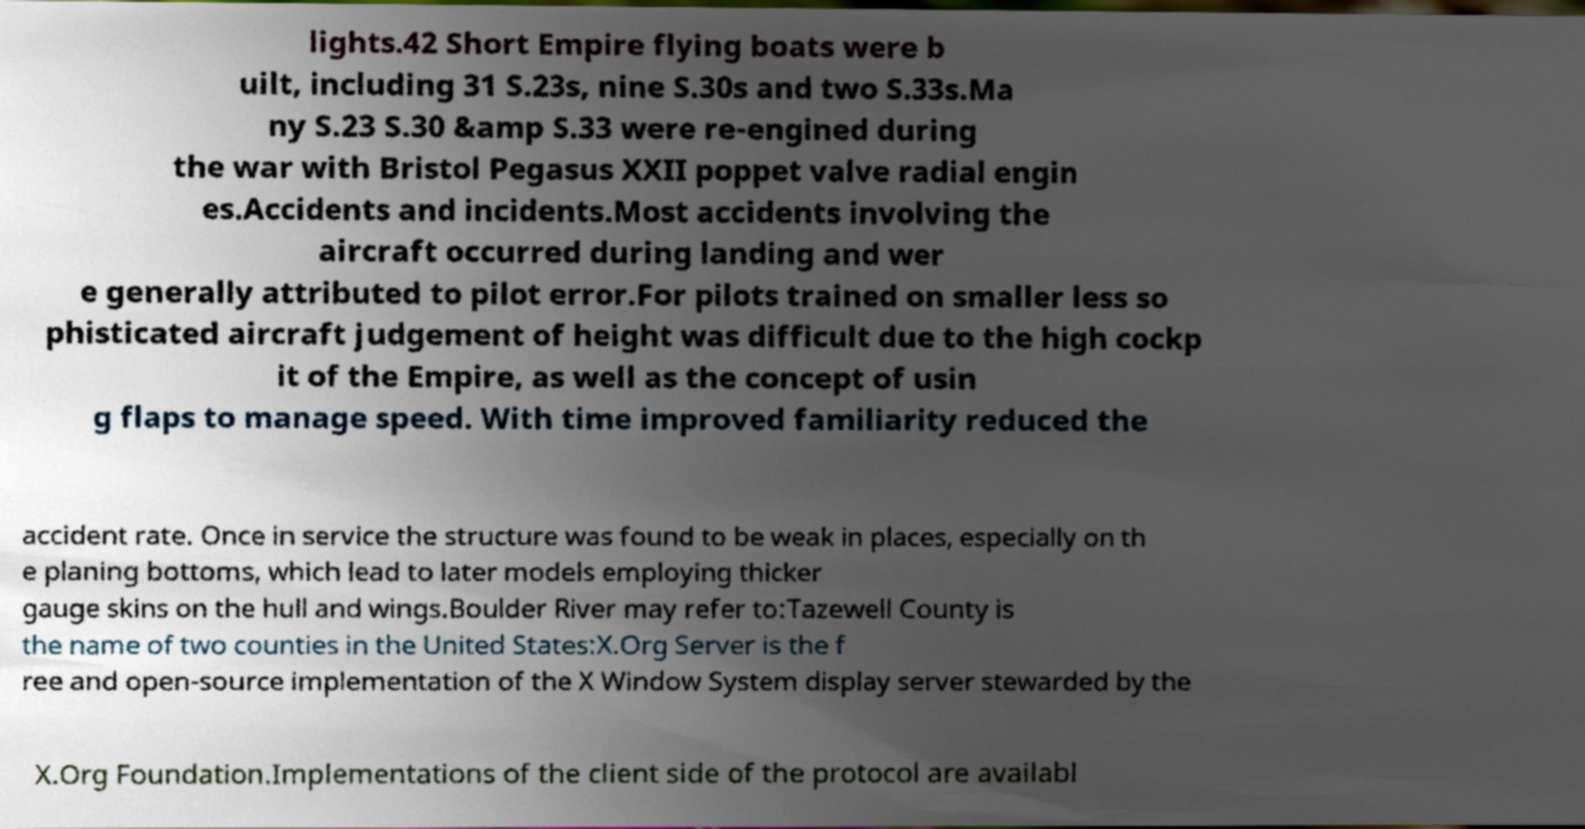I need the written content from this picture converted into text. Can you do that? lights.42 Short Empire flying boats were b uilt, including 31 S.23s, nine S.30s and two S.33s.Ma ny S.23 S.30 &amp S.33 were re-engined during the war with Bristol Pegasus XXII poppet valve radial engin es.Accidents and incidents.Most accidents involving the aircraft occurred during landing and wer e generally attributed to pilot error.For pilots trained on smaller less so phisticated aircraft judgement of height was difficult due to the high cockp it of the Empire, as well as the concept of usin g flaps to manage speed. With time improved familiarity reduced the accident rate. Once in service the structure was found to be weak in places, especially on th e planing bottoms, which lead to later models employing thicker gauge skins on the hull and wings.Boulder River may refer to:Tazewell County is the name of two counties in the United States:X.Org Server is the f ree and open-source implementation of the X Window System display server stewarded by the X.Org Foundation.Implementations of the client side of the protocol are availabl 